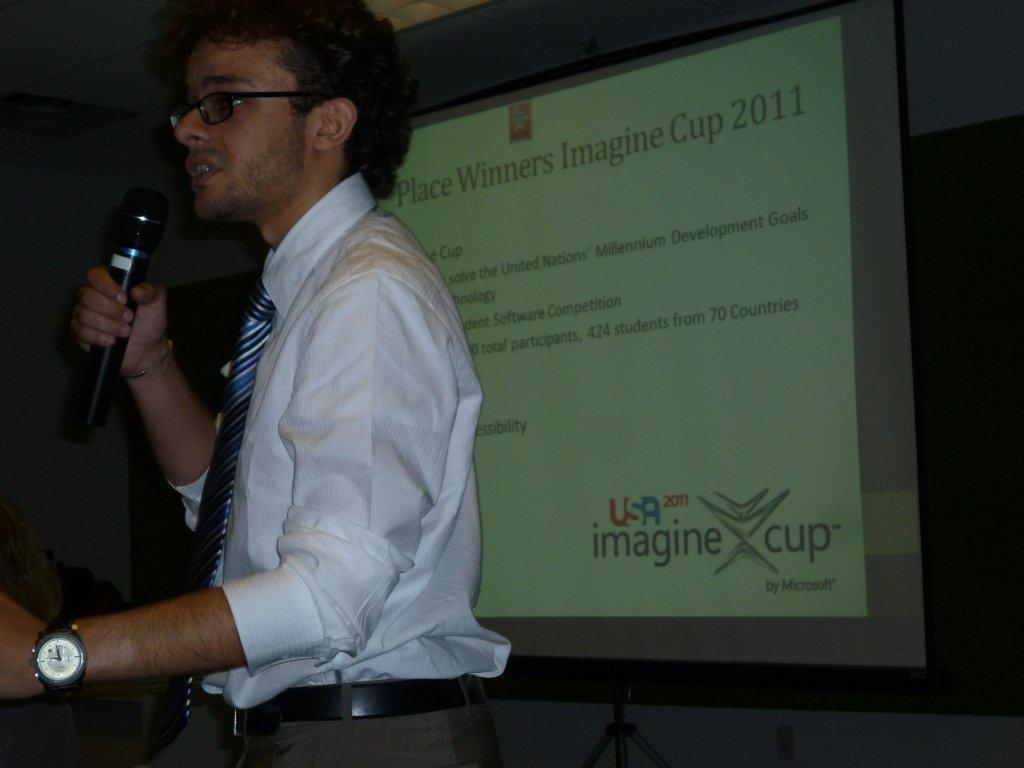What is the main subject of the image? There is a person in the image. What is the person doing in the image? The person is talking into a microphone. Can you see any roads, trays, or fans in the image? No, there are no roads, trays, or fans visible in the image. 